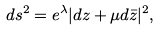Convert formula to latex. <formula><loc_0><loc_0><loc_500><loc_500>d s ^ { 2 } = e ^ { \lambda } | d z + \mu d \bar { z } | ^ { 2 } ,</formula> 